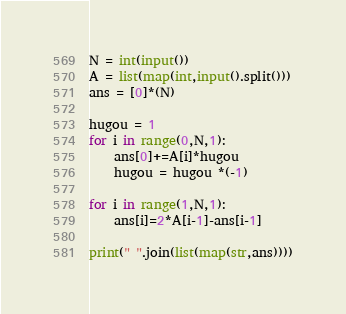Convert code to text. <code><loc_0><loc_0><loc_500><loc_500><_Python_>N = int(input())
A = list(map(int,input().split()))
ans = [0]*(N)

hugou = 1
for i in range(0,N,1):
    ans[0]+=A[i]*hugou
    hugou = hugou *(-1)

for i in range(1,N,1):
    ans[i]=2*A[i-1]-ans[i-1]

print(" ".join(list(map(str,ans))))
</code> 